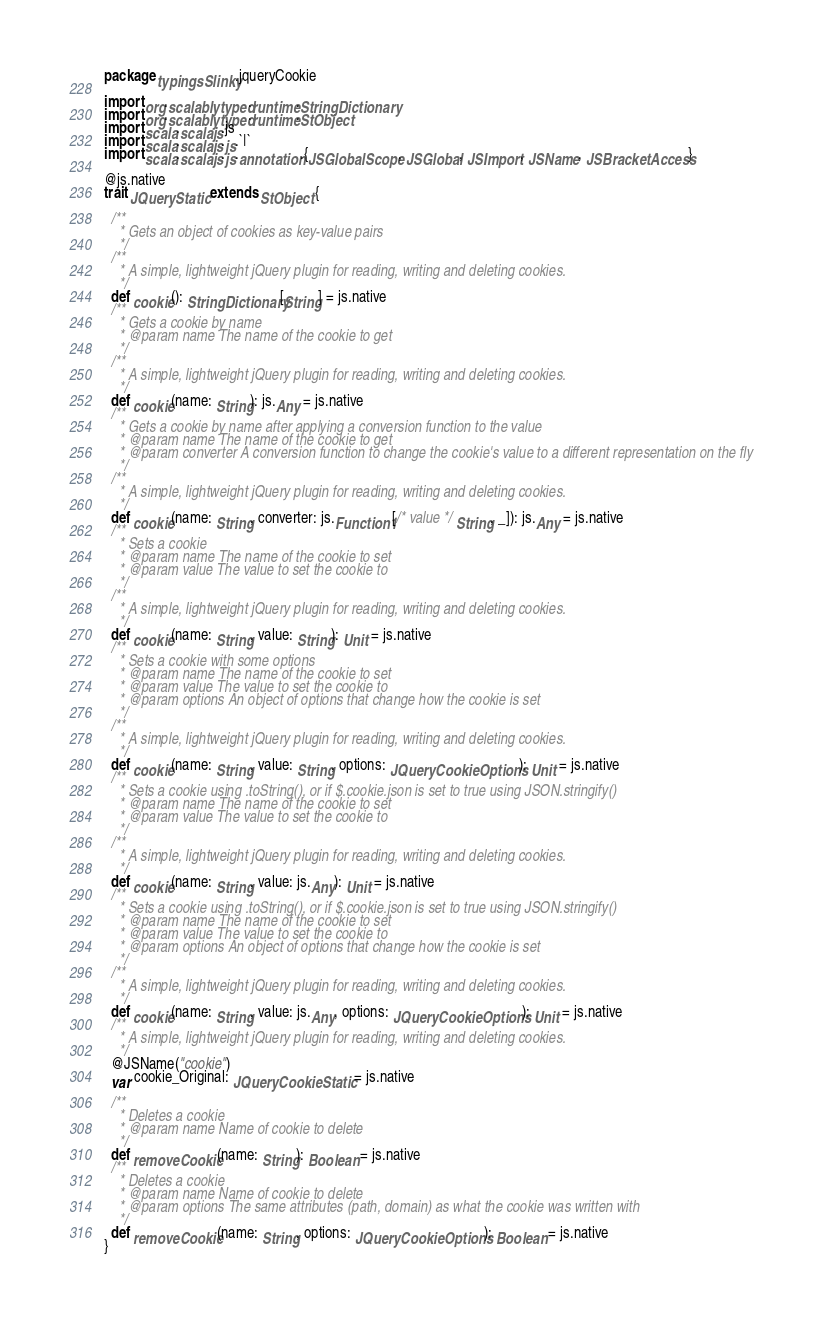Convert code to text. <code><loc_0><loc_0><loc_500><loc_500><_Scala_>package typingsSlinky.jqueryCookie

import org.scalablytyped.runtime.StringDictionary
import org.scalablytyped.runtime.StObject
import scala.scalajs.js
import scala.scalajs.js.`|`
import scala.scalajs.js.annotation.{JSGlobalScope, JSGlobal, JSImport, JSName, JSBracketAccess}

@js.native
trait JQueryStatic extends StObject {
  
  /**
    * Gets an object of cookies as key-value pairs
    */
  /**
    * A simple, lightweight jQuery plugin for reading, writing and deleting cookies.
    */
  def cookie(): StringDictionary[String] = js.native
  /**
    * Gets a cookie by name
    * @param name The name of the cookie to get
    */
  /**
    * A simple, lightweight jQuery plugin for reading, writing and deleting cookies.
    */
  def cookie(name: String): js.Any = js.native
  /**
    * Gets a cookie by name after applying a conversion function to the value
    * @param name The name of the cookie to get
    * @param converter A conversion function to change the cookie's value to a different representation on the fly
    */
  /**
    * A simple, lightweight jQuery plugin for reading, writing and deleting cookies.
    */
  def cookie(name: String, converter: js.Function1[/* value */ String, _]): js.Any = js.native
  /**
    * Sets a cookie
    * @param name The name of the cookie to set
    * @param value The value to set the cookie to
    */
  /**
    * A simple, lightweight jQuery plugin for reading, writing and deleting cookies.
    */
  def cookie(name: String, value: String): Unit = js.native
  /**
    * Sets a cookie with some options
    * @param name The name of the cookie to set
    * @param value The value to set the cookie to
    * @param options An object of options that change how the cookie is set
    */
  /**
    * A simple, lightweight jQuery plugin for reading, writing and deleting cookies.
    */
  def cookie(name: String, value: String, options: JQueryCookieOptions): Unit = js.native
  /**
    * Sets a cookie using .toString(), or if $.cookie.json is set to true using JSON.stringify()
    * @param name The name of the cookie to set
    * @param value The value to set the cookie to
    */
  /**
    * A simple, lightweight jQuery plugin for reading, writing and deleting cookies.
    */
  def cookie(name: String, value: js.Any): Unit = js.native
  /**
    * Sets a cookie using .toString(), or if $.cookie.json is set to true using JSON.stringify()
    * @param name The name of the cookie to set
    * @param value The value to set the cookie to
    * @param options An object of options that change how the cookie is set
    */
  /**
    * A simple, lightweight jQuery plugin for reading, writing and deleting cookies.
    */
  def cookie(name: String, value: js.Any, options: JQueryCookieOptions): Unit = js.native
  /**
    * A simple, lightweight jQuery plugin for reading, writing and deleting cookies.
    */
  @JSName("cookie")
  var cookie_Original: JQueryCookieStatic = js.native
  
  /**
    * Deletes a cookie
    * @param name Name of cookie to delete
    */
  def removeCookie(name: String): Boolean = js.native
  /**
    * Deletes a cookie
    * @param name Name of cookie to delete
    * @param options The same attributes (path, domain) as what the cookie was written with
    */
  def removeCookie(name: String, options: JQueryCookieOptions): Boolean = js.native
}
</code> 